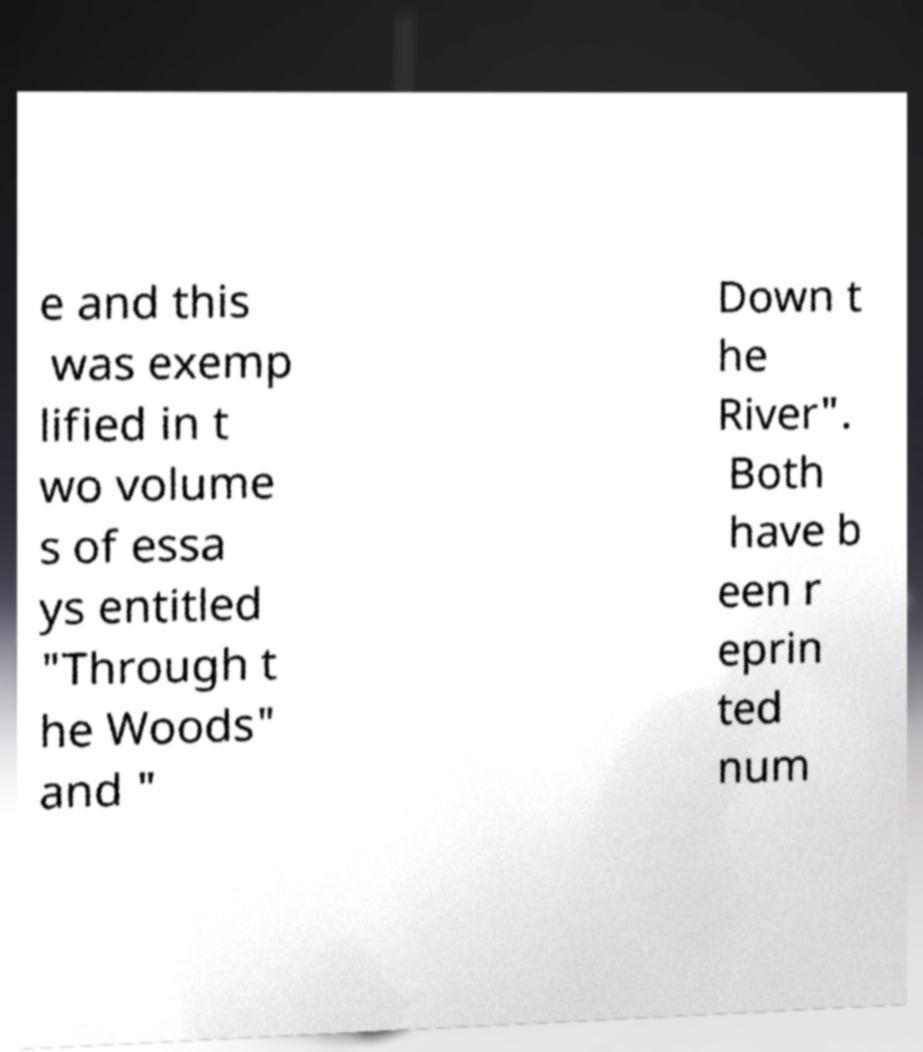For documentation purposes, I need the text within this image transcribed. Could you provide that? e and this was exemp lified in t wo volume s of essa ys entitled "Through t he Woods" and " Down t he River". Both have b een r eprin ted num 